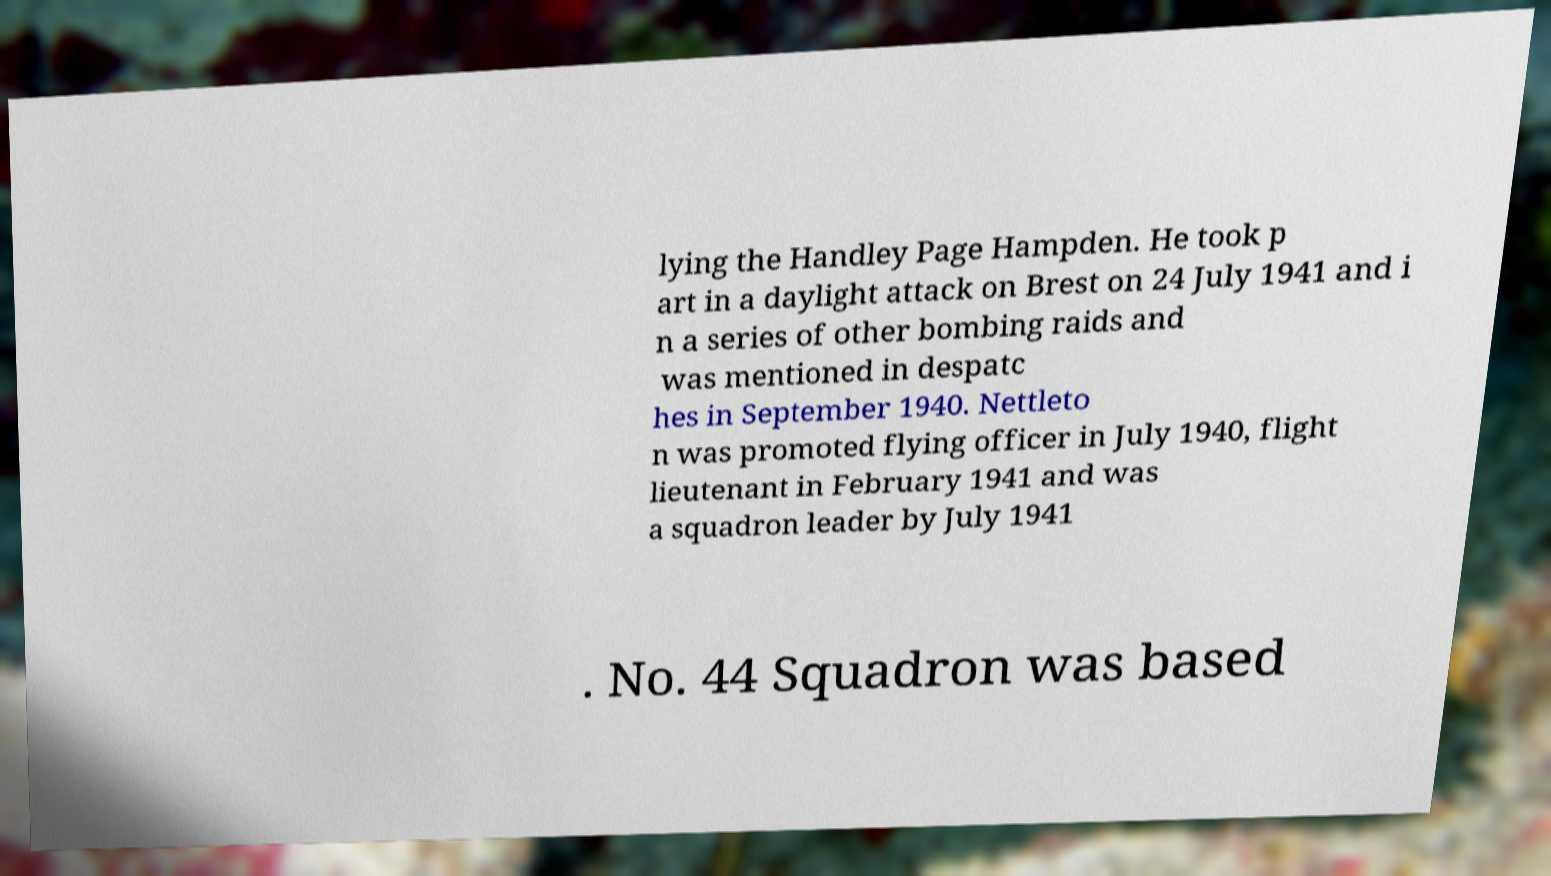Please identify and transcribe the text found in this image. lying the Handley Page Hampden. He took p art in a daylight attack on Brest on 24 July 1941 and i n a series of other bombing raids and was mentioned in despatc hes in September 1940. Nettleto n was promoted flying officer in July 1940, flight lieutenant in February 1941 and was a squadron leader by July 1941 . No. 44 Squadron was based 